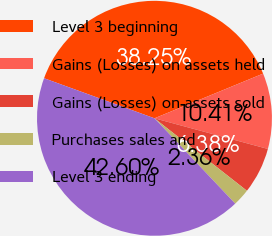<chart> <loc_0><loc_0><loc_500><loc_500><pie_chart><fcel>Level 3 beginning<fcel>Gains (Losses) on assets held<fcel>Gains (Losses) on assets sold<fcel>Purchases sales and<fcel>Level 3 ending<nl><fcel>38.25%<fcel>10.41%<fcel>6.38%<fcel>2.36%<fcel>42.6%<nl></chart> 